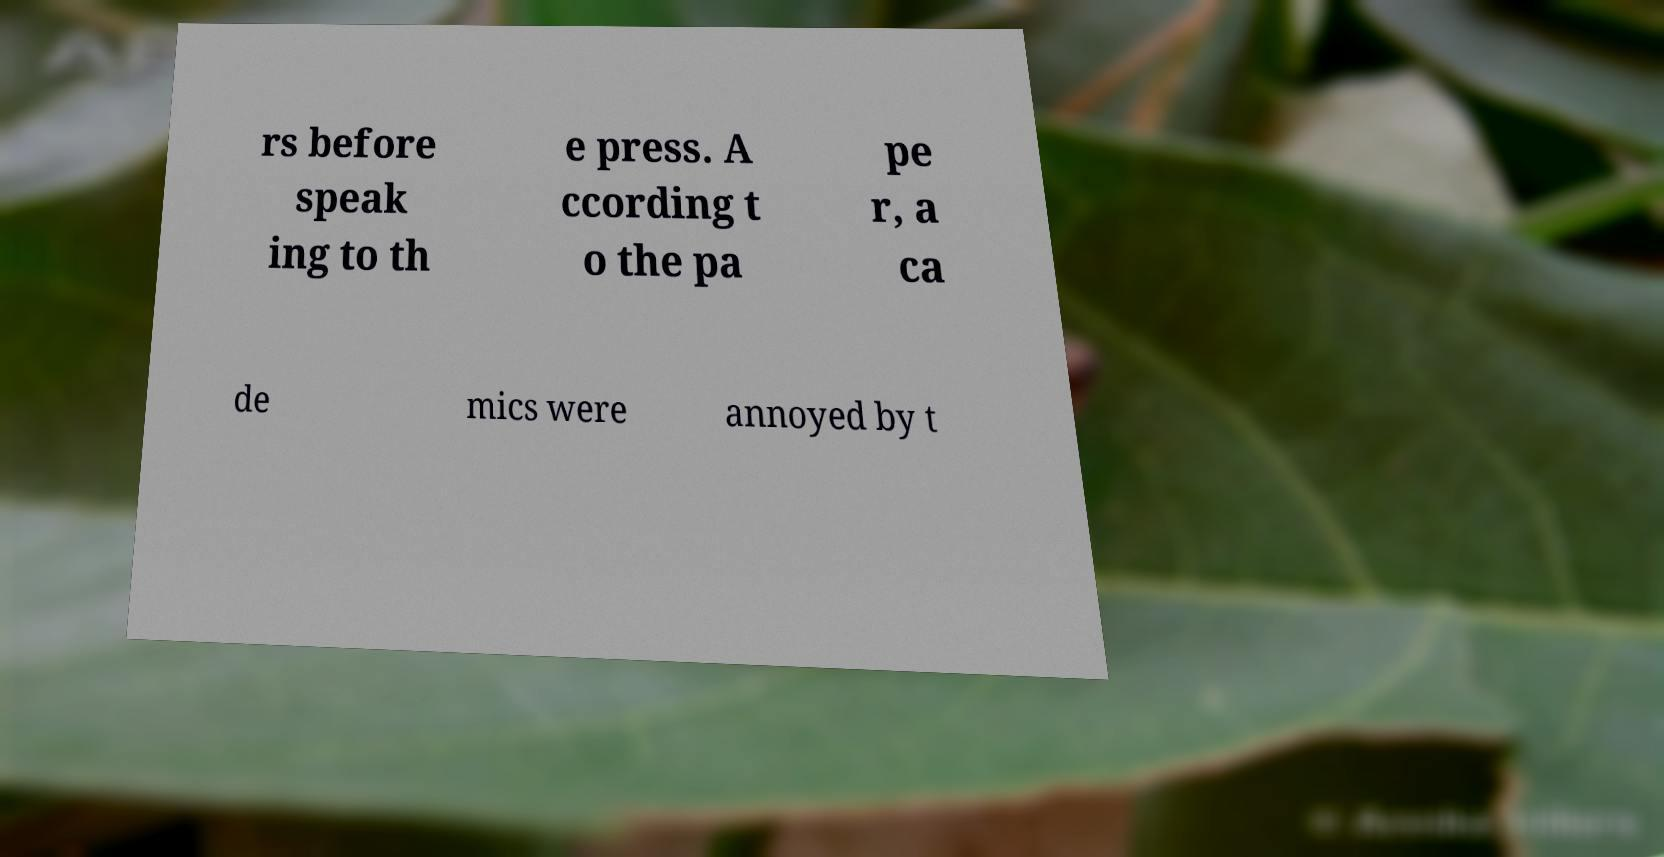Please identify and transcribe the text found in this image. rs before speak ing to th e press. A ccording t o the pa pe r, a ca de mics were annoyed by t 